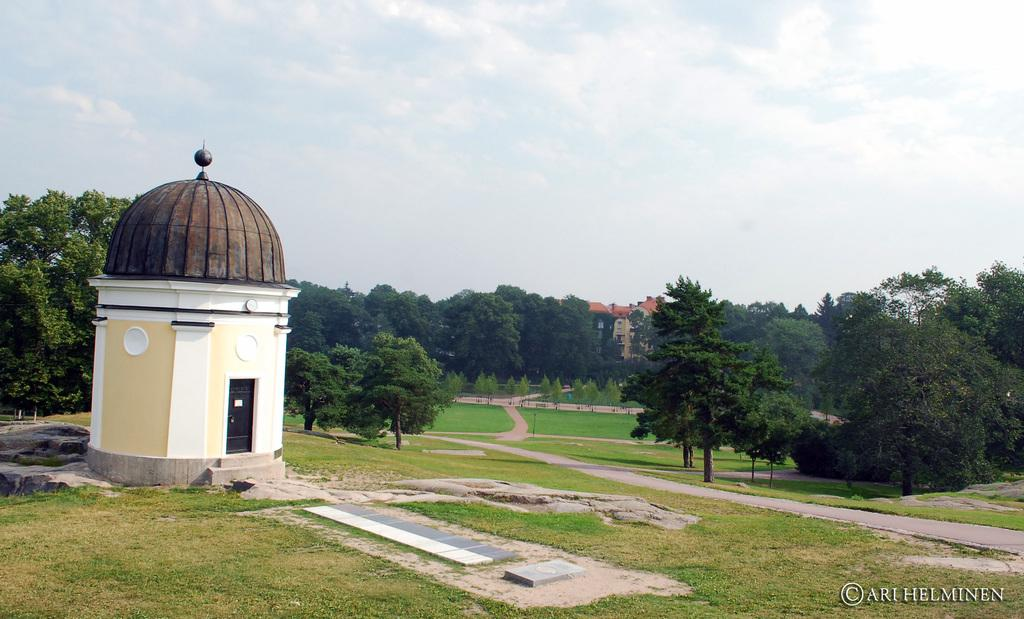What is located on the left side of the image? There is a room on the left side of the image. What architectural feature can be seen in the image? There is a door in the image. What is covering the room in the image? There is a roof in the image. What type of vegetation is visible in the background? Grass is visible on the ground in the background. What structures are present in the background? Poles, trees, and buildings are visible in the background. What is visible in the sky in the background? Clouds are visible in the sky in the background. What type of store can be seen in the image? There is no store present in the image. Can you tell me how many people are sailing in the image? There is no sailing or any indication of water in the image. 